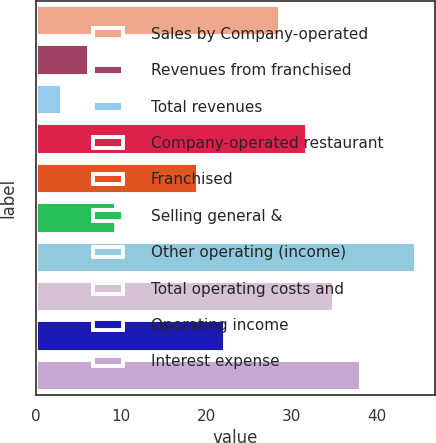Convert chart. <chart><loc_0><loc_0><loc_500><loc_500><bar_chart><fcel>Sales by Company-operated<fcel>Revenues from franchised<fcel>Total revenues<fcel>Company-operated restaurant<fcel>Franchised<fcel>Selling general &<fcel>Other operating (income)<fcel>Total operating costs and<fcel>Operating income<fcel>Interest expense<nl><fcel>28.6<fcel>6.2<fcel>3<fcel>31.8<fcel>19<fcel>9.4<fcel>44.6<fcel>35<fcel>22.2<fcel>38.2<nl></chart> 